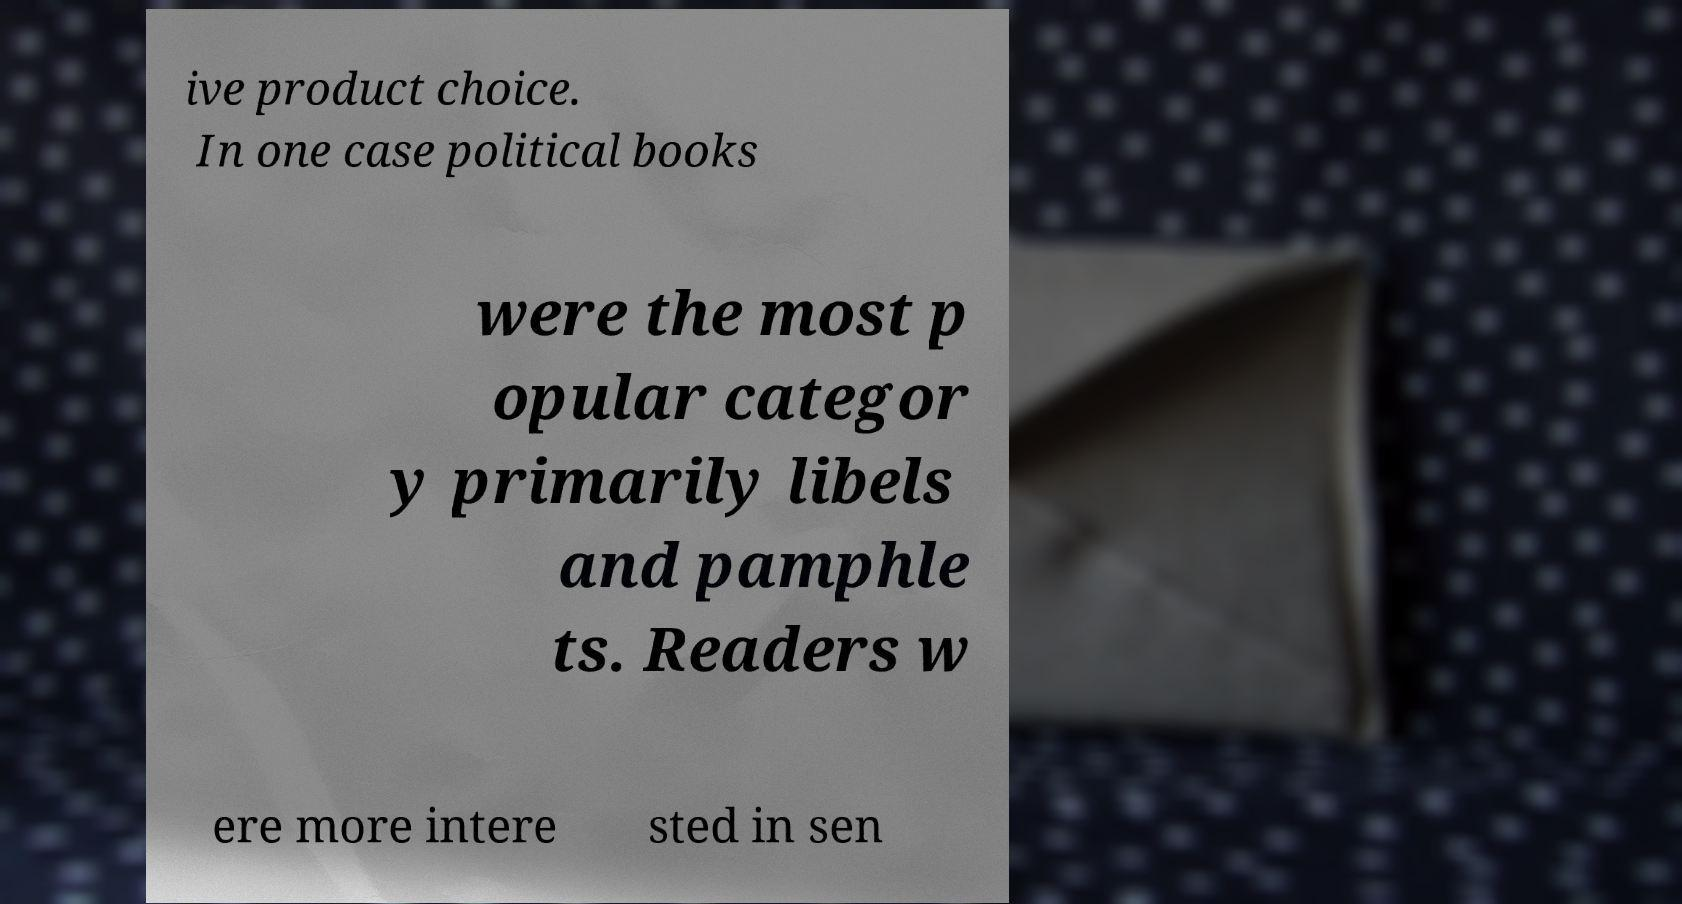Could you assist in decoding the text presented in this image and type it out clearly? ive product choice. In one case political books were the most p opular categor y primarily libels and pamphle ts. Readers w ere more intere sted in sen 